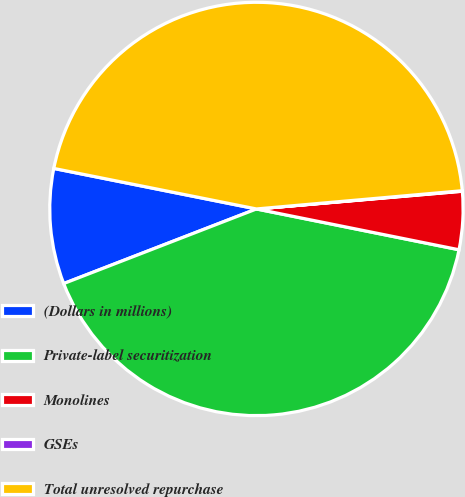Convert chart to OTSL. <chart><loc_0><loc_0><loc_500><loc_500><pie_chart><fcel>(Dollars in millions)<fcel>Private-label securitization<fcel>Monolines<fcel>GSEs<fcel>Total unresolved repurchase<nl><fcel>9.02%<fcel>40.96%<fcel>4.53%<fcel>0.04%<fcel>45.45%<nl></chart> 